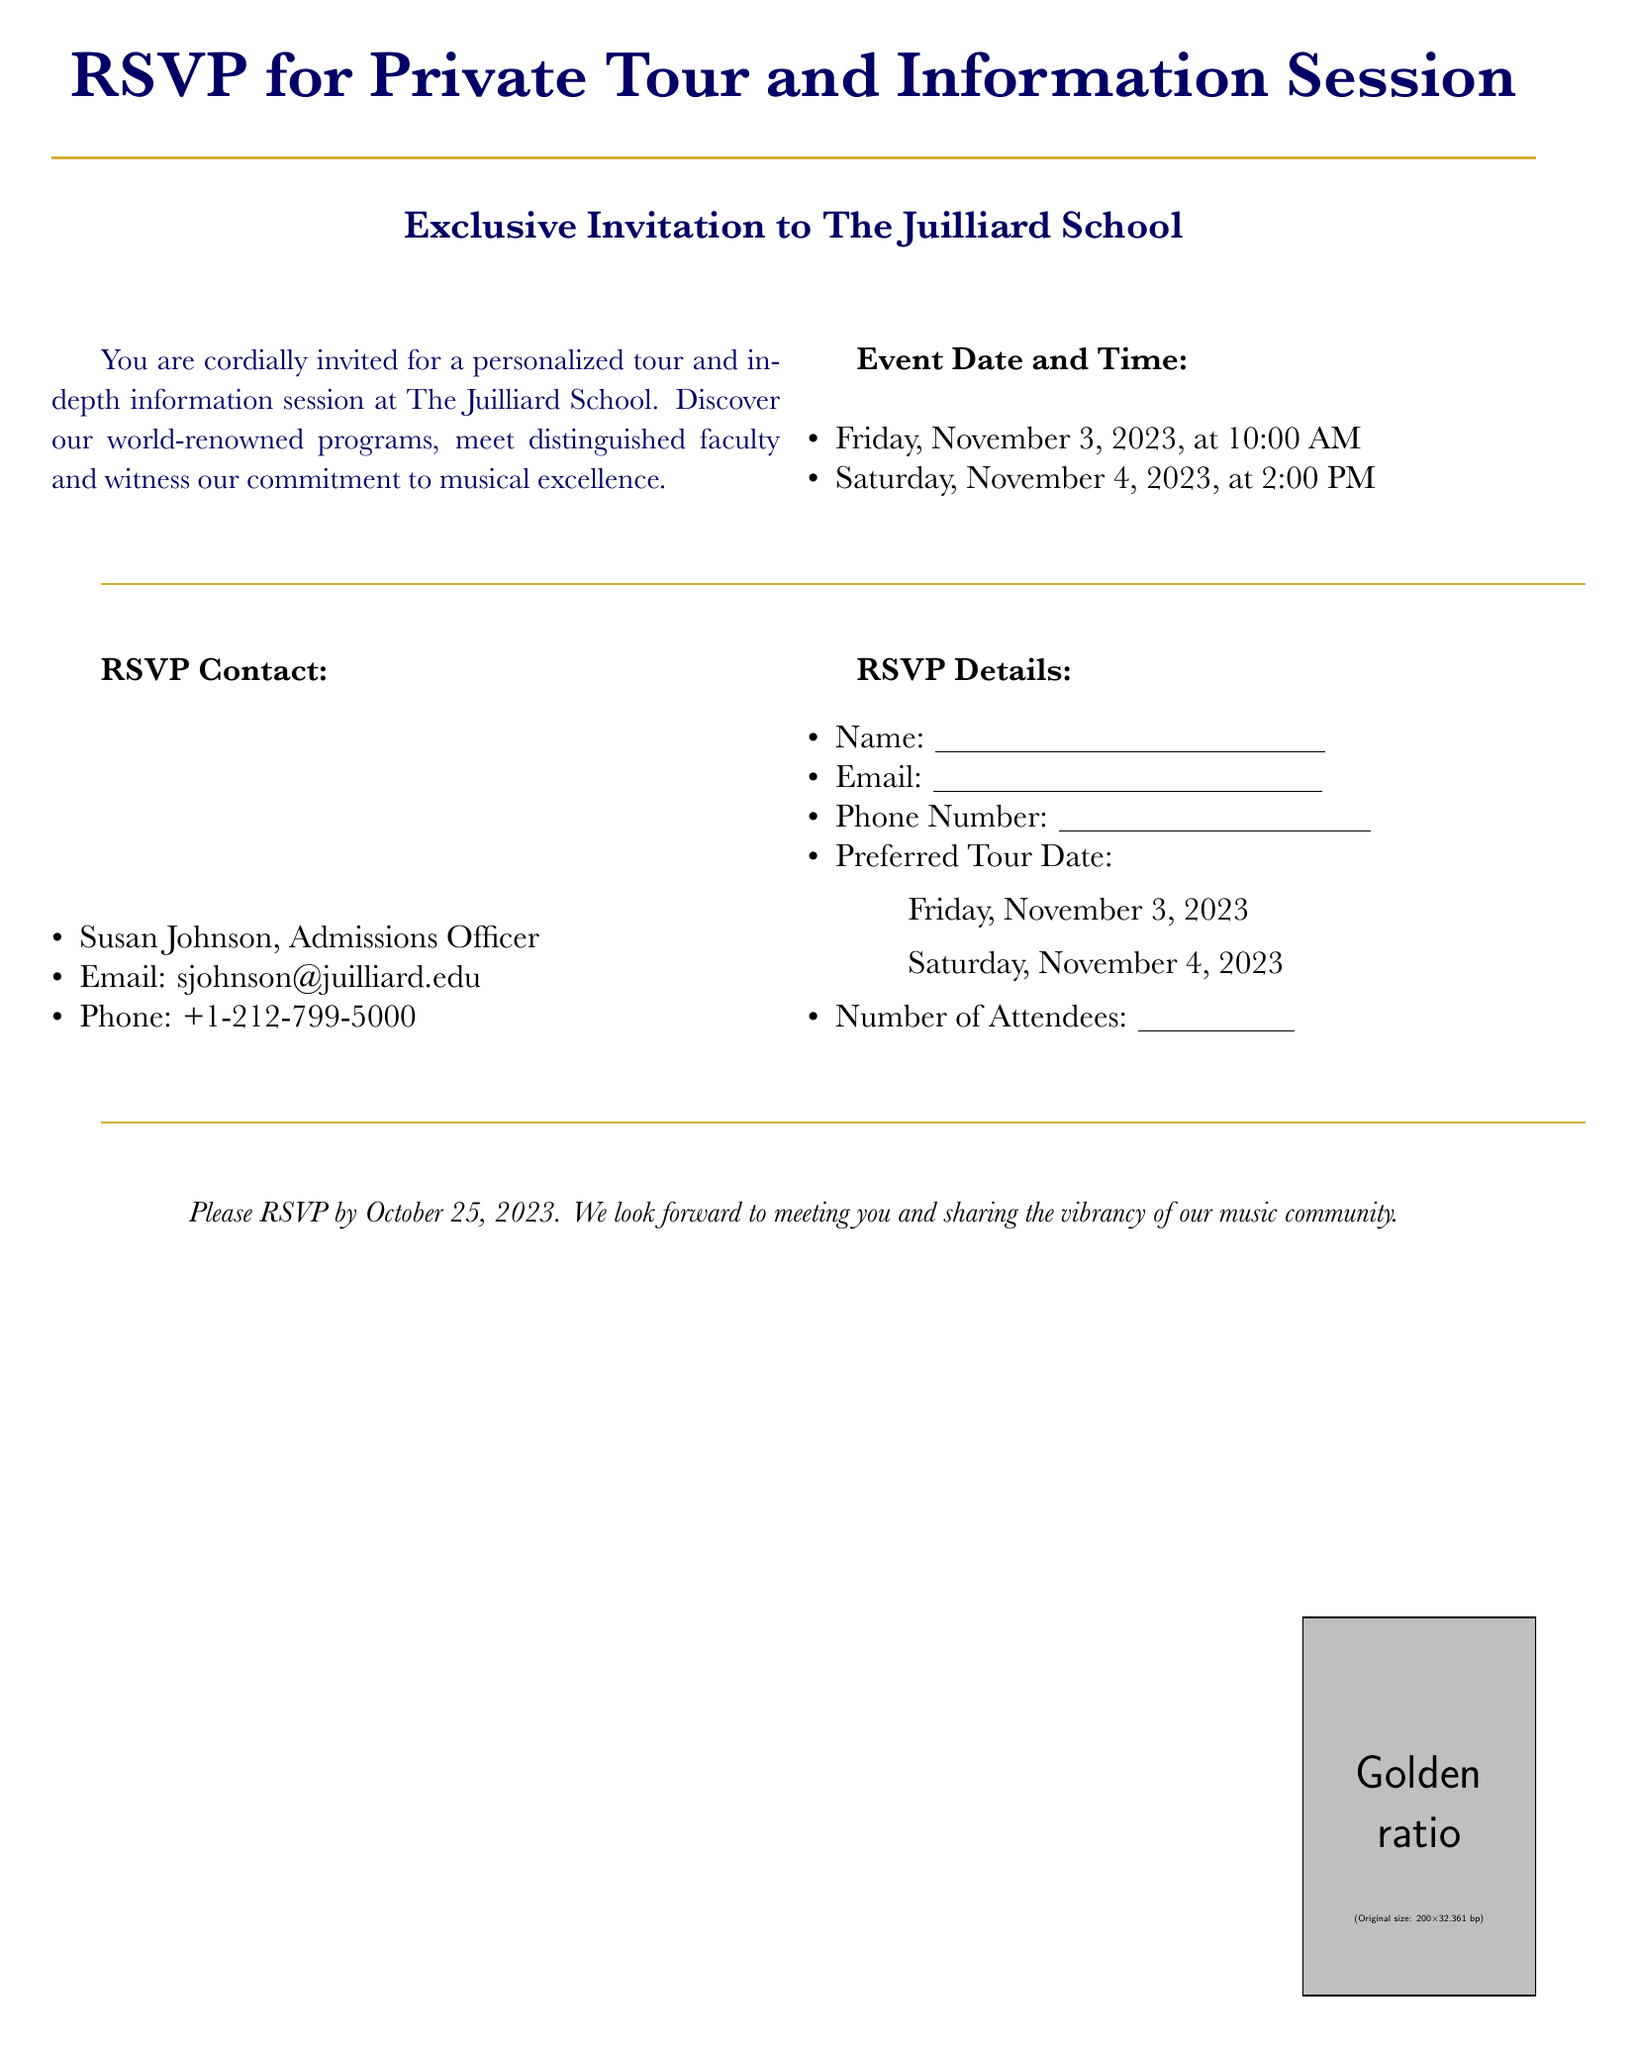what is the name of the school hosting the event? The name of the school is mentioned at the top of the RSVP card.
Answer: The Juilliard School what are the event dates for the tour? The RSVP card lists two specific dates for the event.
Answer: November 3, 2023 and November 4, 2023 who should be contacted for RSVP? The document specifies the name of the admissions officer for RSVP.
Answer: Susan Johnson what time is the event on November 4, 2023? The document provides the specific time for the event on that date.
Answer: 2:00 PM by what date must attendees RSVP? The RSVP card indicates a deadline for RSVPs in the details section.
Answer: October 25, 2023 how many attendees can be indicated on the RSVP? The RSVP details section specifies a space for the number of attendees.
Answer: 2 what is the email address for RSVPs? The document contains a specific email address for RSVPs.
Answer: sjohnson@juilliard.edu what is the purpose of the event? The RSVP card briefly describes the invitation's intent in the introductory text.
Answer: Personalized tour and information session 